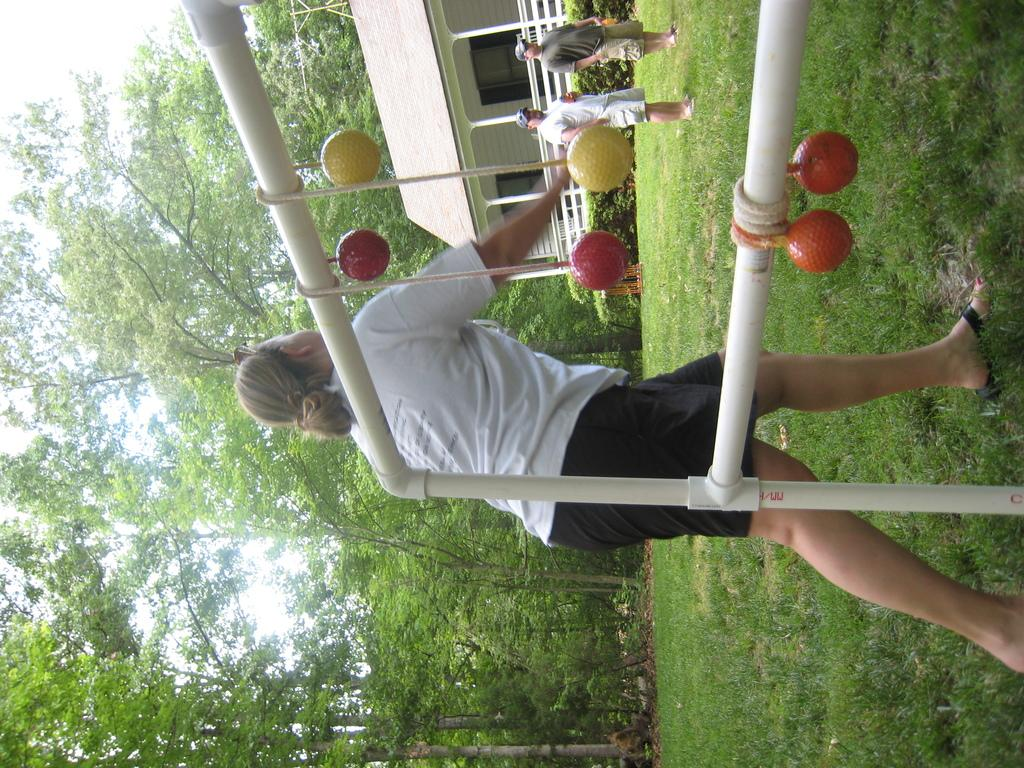What is the primary vegetation covering the land in the image? The land is covered with grass. How many people are present in the image? There are three people standing in the image. What can be seen in the background of the image? There are trees in the background. Can you describe the house in the image? There is a house with windows in the image, and it has a fence in front of it. What else is present in front of the house? There are plants in front of the house. What color is the bucket that the people are using to connect the house to the trees? There is no bucket present in the image, and the people are not connecting the house to the trees. 